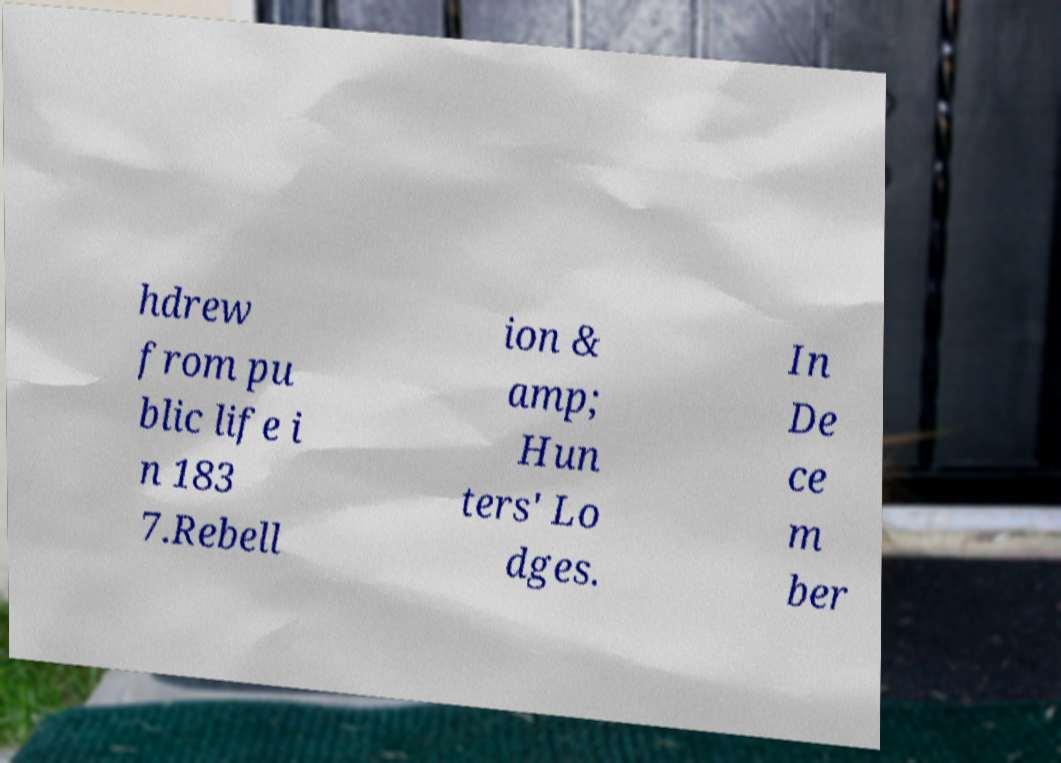Could you extract and type out the text from this image? hdrew from pu blic life i n 183 7.Rebell ion & amp; Hun ters' Lo dges. In De ce m ber 